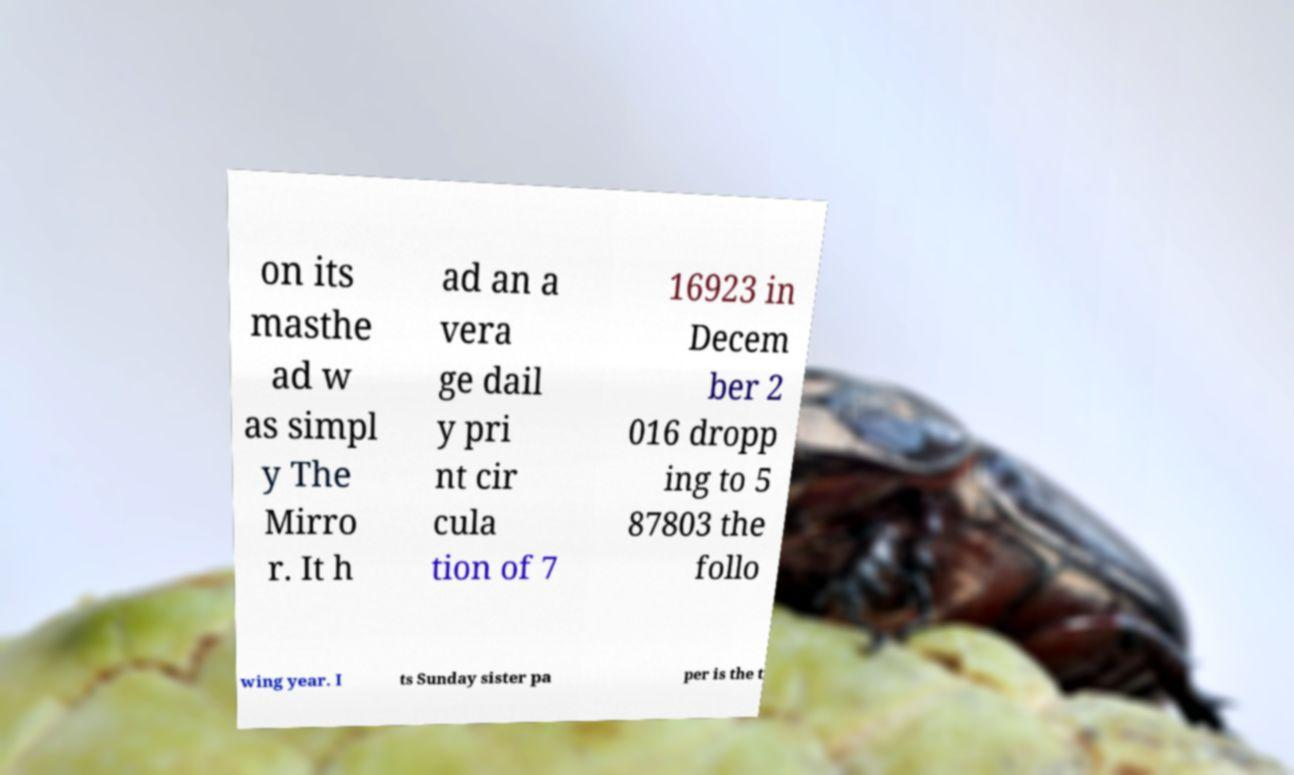Please read and relay the text visible in this image. What does it say? on its masthe ad w as simpl y The Mirro r. It h ad an a vera ge dail y pri nt cir cula tion of 7 16923 in Decem ber 2 016 dropp ing to 5 87803 the follo wing year. I ts Sunday sister pa per is the t 